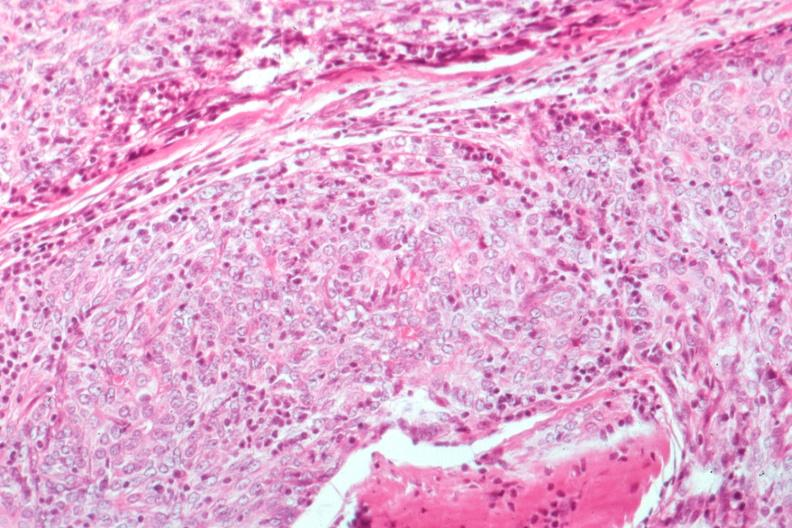s leiomyomas present?
Answer the question using a single word or phrase. No 